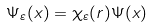<formula> <loc_0><loc_0><loc_500><loc_500>\Psi _ { \varepsilon } ( x ) = \chi _ { \varepsilon } ( r ) \Psi ( x )</formula> 